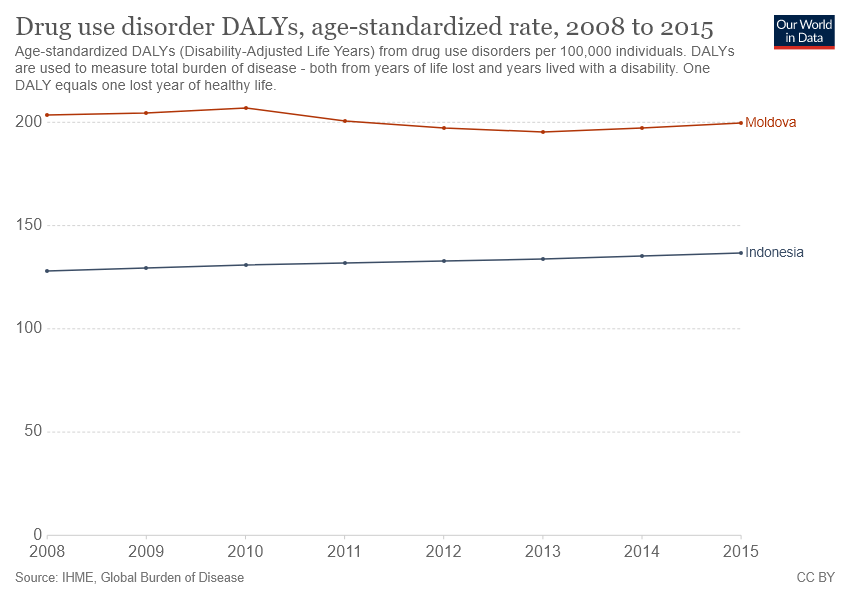Specify some key components in this picture. The age-standardized DALYs rate was less than 200 in 3 years. In 2015, Indonesia recorded the highest age-standardized rate of DALYs (Disability-Adjusted Life Years) among all years, according to available data. 